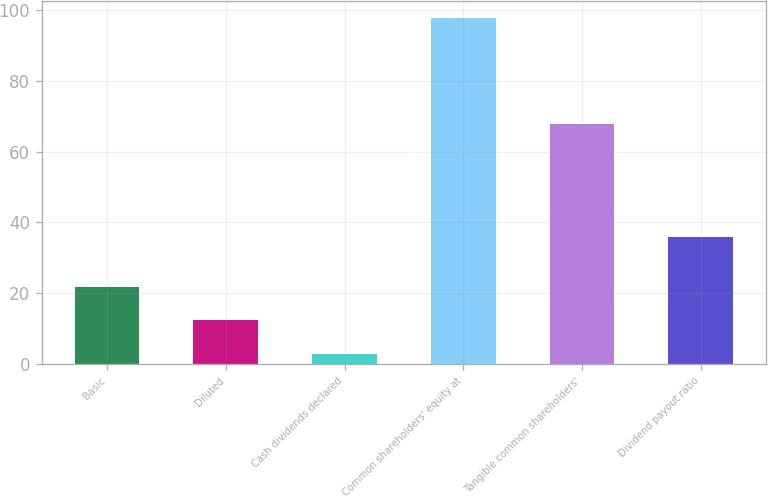<chart> <loc_0><loc_0><loc_500><loc_500><bar_chart><fcel>Basic<fcel>Diluted<fcel>Cash dividends declared<fcel>Common shareholders' equity at<fcel>Tangible common shareholders'<fcel>Dividend payout ratio<nl><fcel>21.76<fcel>12.28<fcel>2.8<fcel>97.64<fcel>67.85<fcel>35.81<nl></chart> 